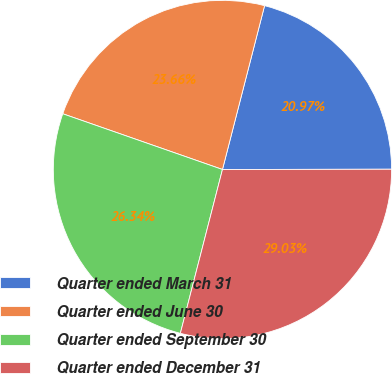<chart> <loc_0><loc_0><loc_500><loc_500><pie_chart><fcel>Quarter ended March 31<fcel>Quarter ended June 30<fcel>Quarter ended September 30<fcel>Quarter ended December 31<nl><fcel>20.97%<fcel>23.66%<fcel>26.34%<fcel>29.03%<nl></chart> 